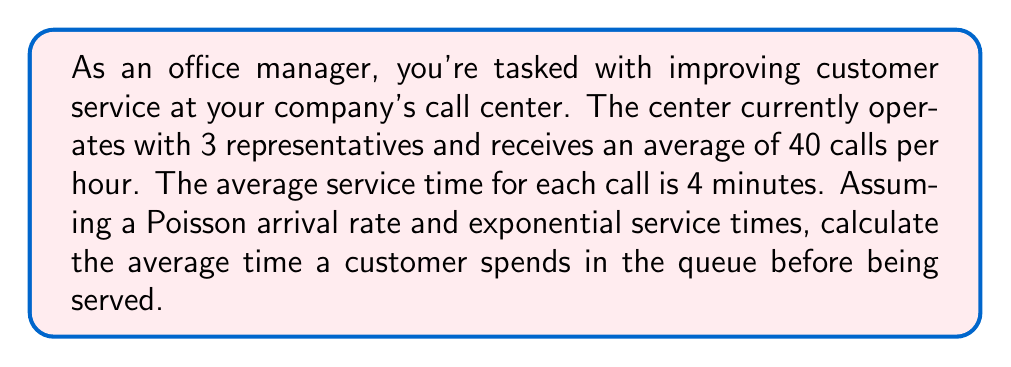What is the answer to this math problem? To solve this problem, we'll use the M/M/s queueing model, where M/M indicates Markovian (Poisson) arrival and service times, and s is the number of servers (representatives in this case).

Given:
- Number of representatives, $s = 3$
- Arrival rate, $\lambda = 40$ calls/hour
- Service rate, $\mu = 60/4 = 15$ calls/hour per representative

Step 1: Calculate the utilization factor, $\rho$
$$\rho = \frac{\lambda}{s\mu} = \frac{40}{3 \times 15} = \frac{40}{45} \approx 0.8889$$

Step 2: Calculate $P_0$, the probability of zero customers in the system
$$P_0 = \left[\sum_{n=0}^{s-1}\frac{(s\rho)^n}{n!} + \frac{(s\rho)^s}{s!(1-\rho)}\right]^{-1}$$
$$P_0 = \left[1 + \frac{40}{1!} + \frac{40^2}{2!} + \frac{40^3}{3!(1-0.8889)}\right]^{-1} \approx 0.0033$$

Step 3: Calculate $L_q$, the average number of customers in the queue
$$L_q = \frac{P_0(s\rho)^s\rho}{s!(1-\rho)^2} = \frac{0.0033 \times 40^3 \times 0.8889}{3!(1-0.8889)^2} \approx 6.4$$

Step 4: Calculate $W_q$, the average time a customer spends in the queue
$$W_q = \frac{L_q}{\lambda} = \frac{6.4}{40} = 0.16 \text{ hours} = 9.6 \text{ minutes}$$
Answer: The average time a customer spends in the queue before being served is approximately 9.6 minutes. 